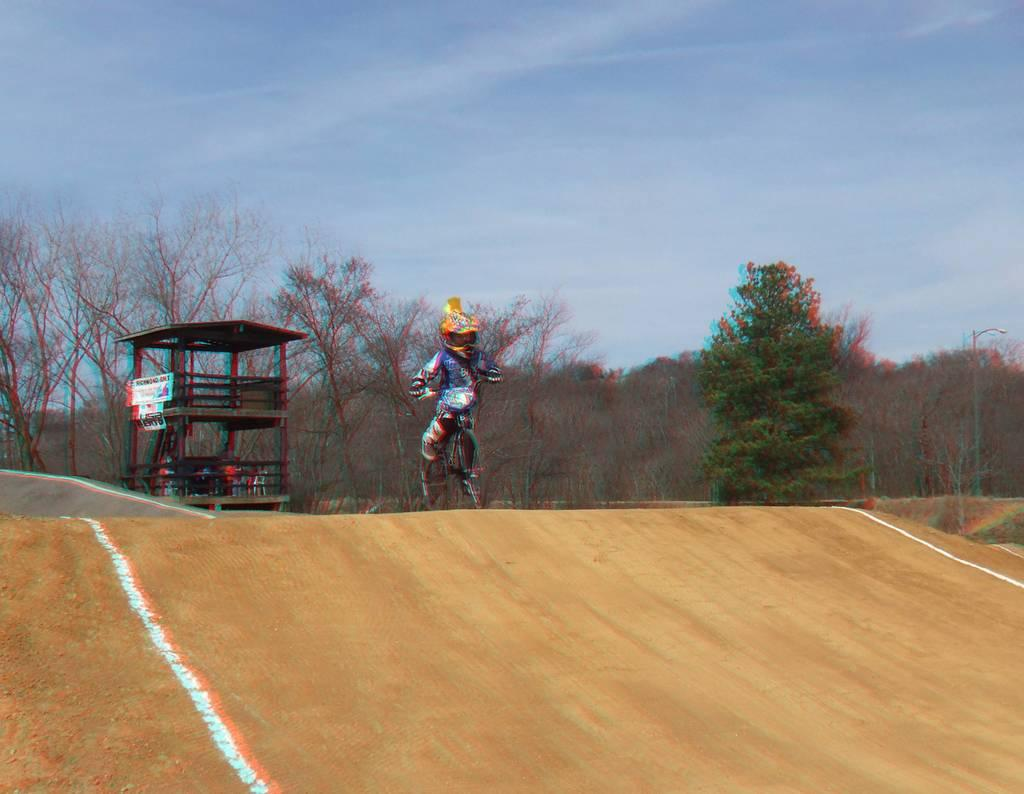What is the main subject in the foreground of the image? There is a boy riding a cycle in the foreground of the image. Where is the boy riding the cycle? The boy is on a path. What can be seen in the background of the image? There is a shelter and trees in the background of the image. What is visible above the shelter and trees? The sky is visible in the background of the image. Can you describe the sky in the image? There is a cloud in the sky. How does the boy adjust the island's position while riding the cycle in the image? There is no island present in the image, and the boy is not adjusting any island's position while riding the cycle. 